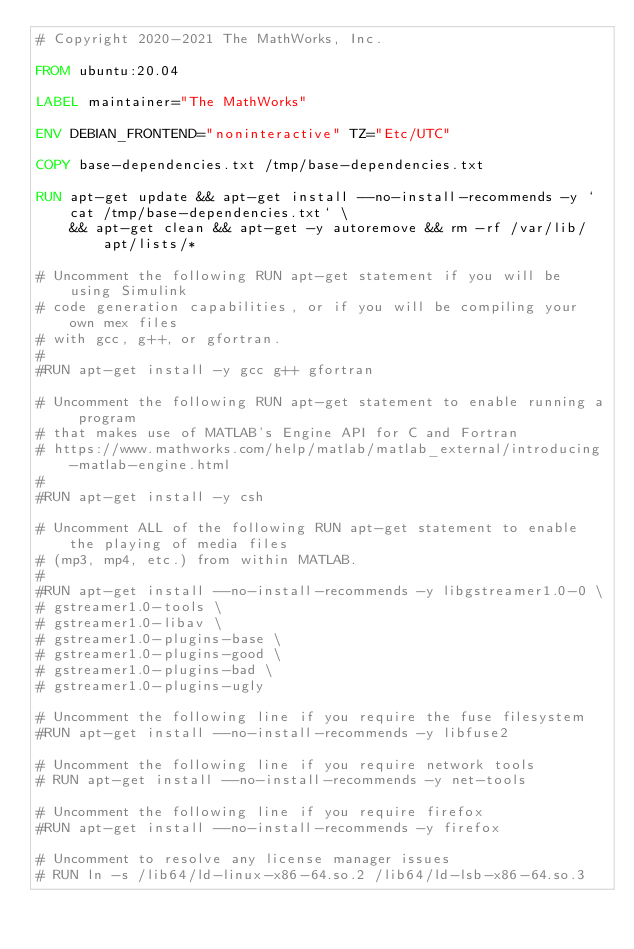Convert code to text. <code><loc_0><loc_0><loc_500><loc_500><_Dockerfile_># Copyright 2020-2021 The MathWorks, Inc.

FROM ubuntu:20.04

LABEL maintainer="The MathWorks"

ENV DEBIAN_FRONTEND="noninteractive" TZ="Etc/UTC"

COPY base-dependencies.txt /tmp/base-dependencies.txt

RUN apt-get update && apt-get install --no-install-recommends -y `cat /tmp/base-dependencies.txt` \
    && apt-get clean && apt-get -y autoremove && rm -rf /var/lib/apt/lists/*

# Uncomment the following RUN apt-get statement if you will be using Simulink 
# code generation capabilities, or if you will be compiling your own mex files
# with gcc, g++, or gfortran.
#
#RUN apt-get install -y gcc g++ gfortran

# Uncomment the following RUN apt-get statement to enable running a program
# that makes use of MATLAB's Engine API for C and Fortran
# https://www.mathworks.com/help/matlab/matlab_external/introducing-matlab-engine.html
#
#RUN apt-get install -y csh

# Uncomment ALL of the following RUN apt-get statement to enable the playing of media files
# (mp3, mp4, etc.) from within MATLAB.
#
#RUN apt-get install --no-install-recommends -y libgstreamer1.0-0 \
# gstreamer1.0-tools \
# gstreamer1.0-libav \
# gstreamer1.0-plugins-base \
# gstreamer1.0-plugins-good \
# gstreamer1.0-plugins-bad \
# gstreamer1.0-plugins-ugly

# Uncomment the following line if you require the fuse filesystem
#RUN apt-get install --no-install-recommends -y libfuse2

# Uncomment the following line if you require network tools
# RUN apt-get install --no-install-recommends -y net-tools

# Uncomment the following line if you require firefox
#RUN apt-get install --no-install-recommends -y firefox

# Uncomment to resolve any license manager issues
# RUN ln -s /lib64/ld-linux-x86-64.so.2 /lib64/ld-lsb-x86-64.so.3
</code> 